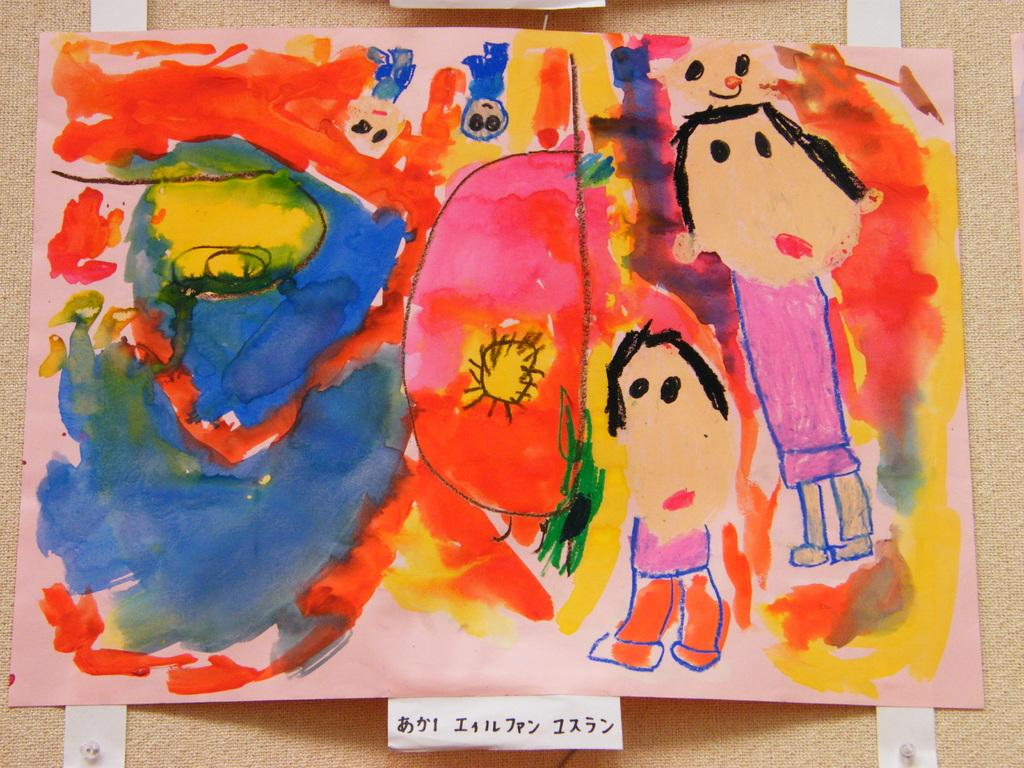What is depicted on the paper in the image? The paper contains a drawing of two persons. Are there any colors used on the paper? Yes, there are colors on the paper. What else can be found at the bottom of the paper? There is text at the bottom of the paper. What type of wax is being used to create the drawing on the paper? There is no wax mentioned or visible in the image; the drawing is created using colors on the paper. 